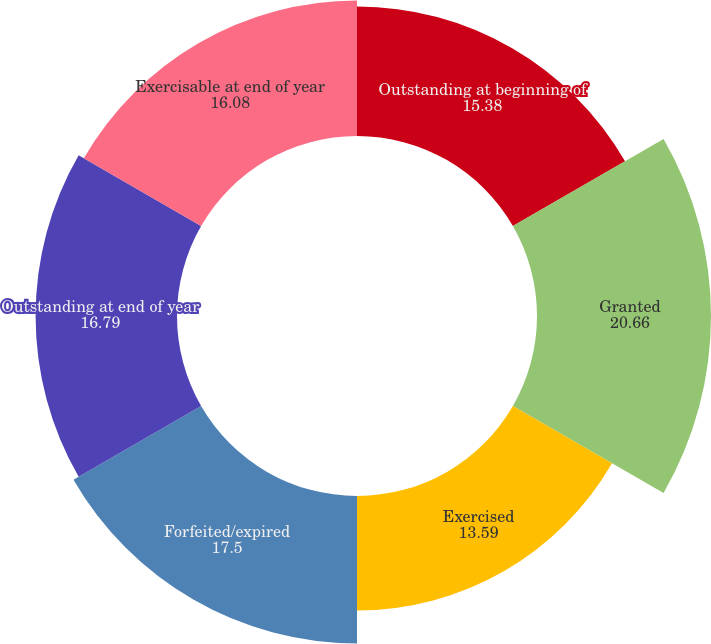Convert chart to OTSL. <chart><loc_0><loc_0><loc_500><loc_500><pie_chart><fcel>Outstanding at beginning of<fcel>Granted<fcel>Exercised<fcel>Forfeited/expired<fcel>Outstanding at end of year<fcel>Exercisable at end of year<nl><fcel>15.38%<fcel>20.66%<fcel>13.59%<fcel>17.5%<fcel>16.79%<fcel>16.08%<nl></chart> 